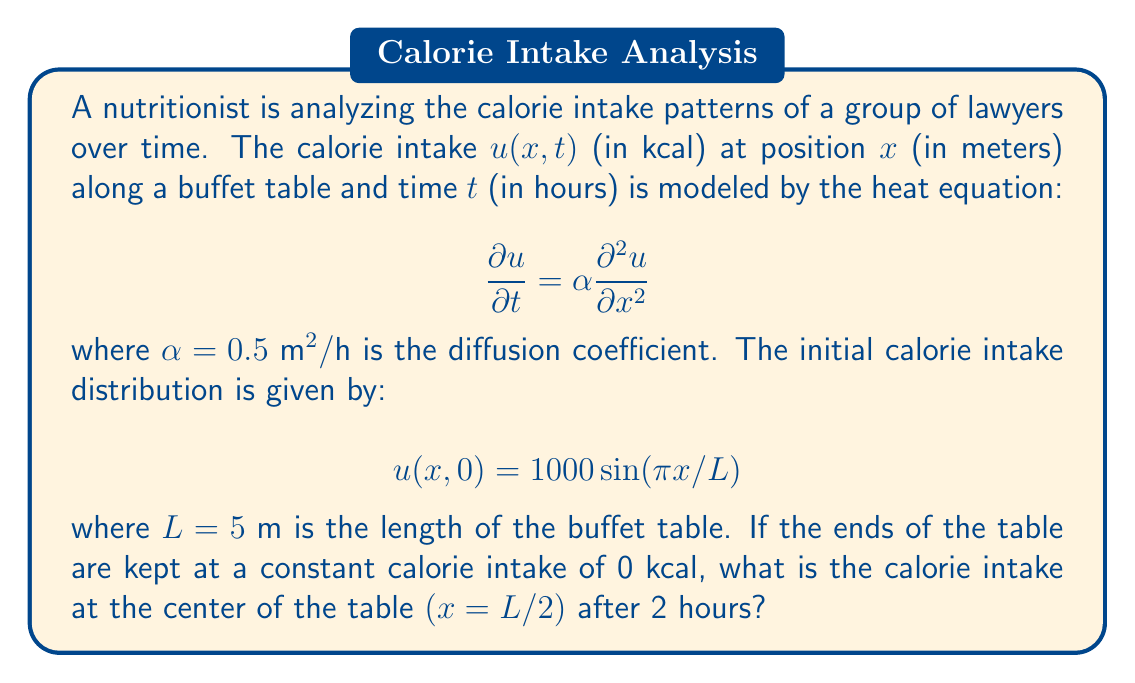Teach me how to tackle this problem. To solve this problem, we need to use the separation of variables method for the heat equation with given initial and boundary conditions.

1) The general solution for the heat equation with these boundary conditions is:

   $$u(x,t) = \sum_{n=1}^{\infty} B_n \sin(\frac{n\pi x}{L}) e^{-\alpha(\frac{n\pi}{L})^2t}$$

2) Given the initial condition, we can see that only the first term $(n=1)$ of the series matches:

   $$u(x,0) = B_1 \sin(\frac{\pi x}{L}) = 1000 \sin(\frac{\pi x}{L})$$

3) Therefore, $B_1 = 1000$ and all other $B_n = 0$ for $n > 1$.

4) Our solution simplifies to:

   $$u(x,t) = 1000 \sin(\frac{\pi x}{L}) e^{-\alpha(\frac{\pi}{L})^2t}$$

5) We want to find $u(L/2, 2)$. Substituting the values:

   $$u(L/2, 2) = 1000 \sin(\frac{\pi (L/2)}{L}) e^{-0.5(\frac{\pi}{5})^2 \cdot 2}$$

6) Simplify:
   
   $$u(L/2, 2) = 1000 \sin(\frac{\pi}{2}) e^{-0.1\pi^2}$$

7) Calculate:
   
   $$u(L/2, 2) = 1000 \cdot 1 \cdot e^{-0.1\pi^2} \approx 374.51$$
Answer: The calorie intake at the center of the table after 2 hours is approximately 374.51 kcal. 